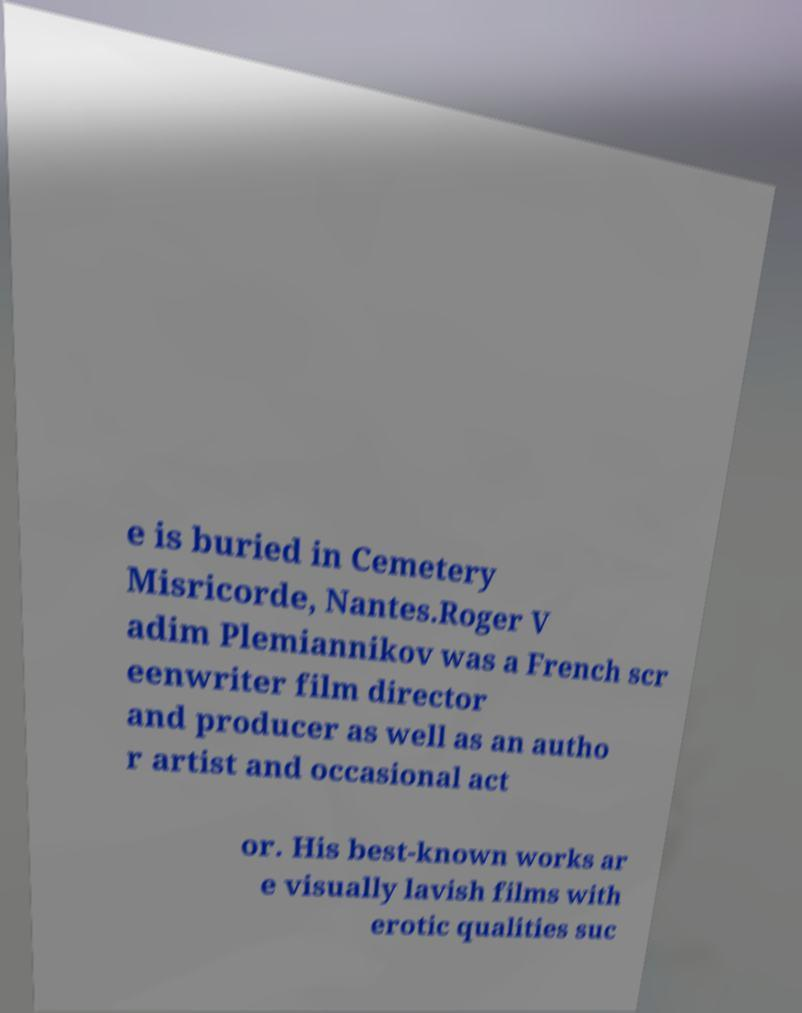For documentation purposes, I need the text within this image transcribed. Could you provide that? e is buried in Cemetery Misricorde, Nantes.Roger V adim Plemiannikov was a French scr eenwriter film director and producer as well as an autho r artist and occasional act or. His best-known works ar e visually lavish films with erotic qualities suc 